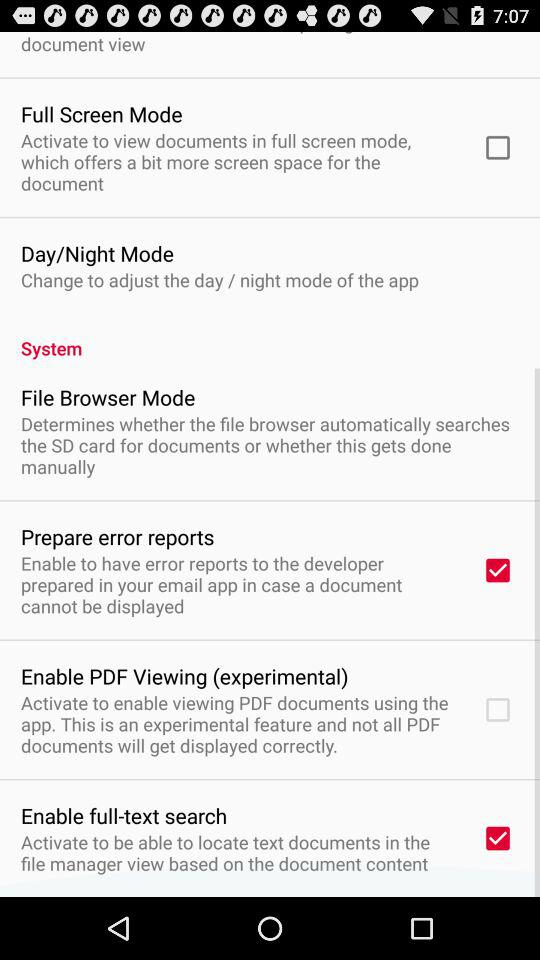What is the status of "Enable full-text search"? The status is on. 